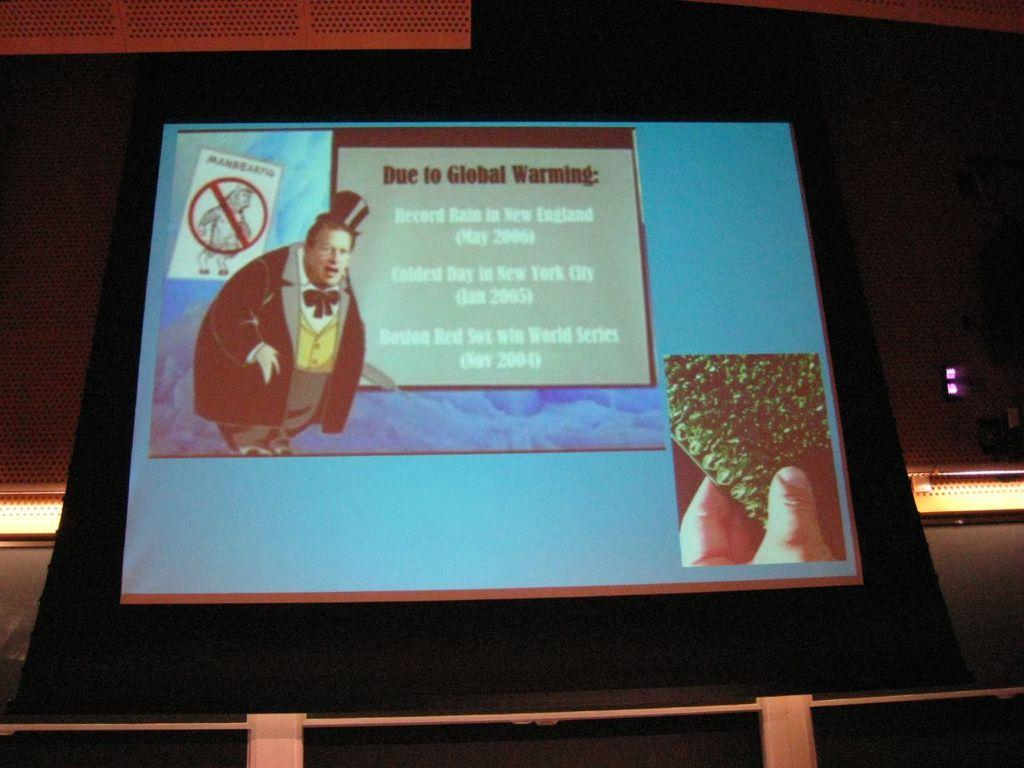What is the main object in the image? There is a screen in the image. What is displayed on the screen? A caution board is displayed on the screen. Who is present near the screen? There is a man standing beside the screen. What can be seen at the bottom of the image? Lights are present at the bottom of the image. How many points does the bridge have in the image? There is no bridge present in the image. What type of channel is visible in the image? There is no channel visible in the image. 